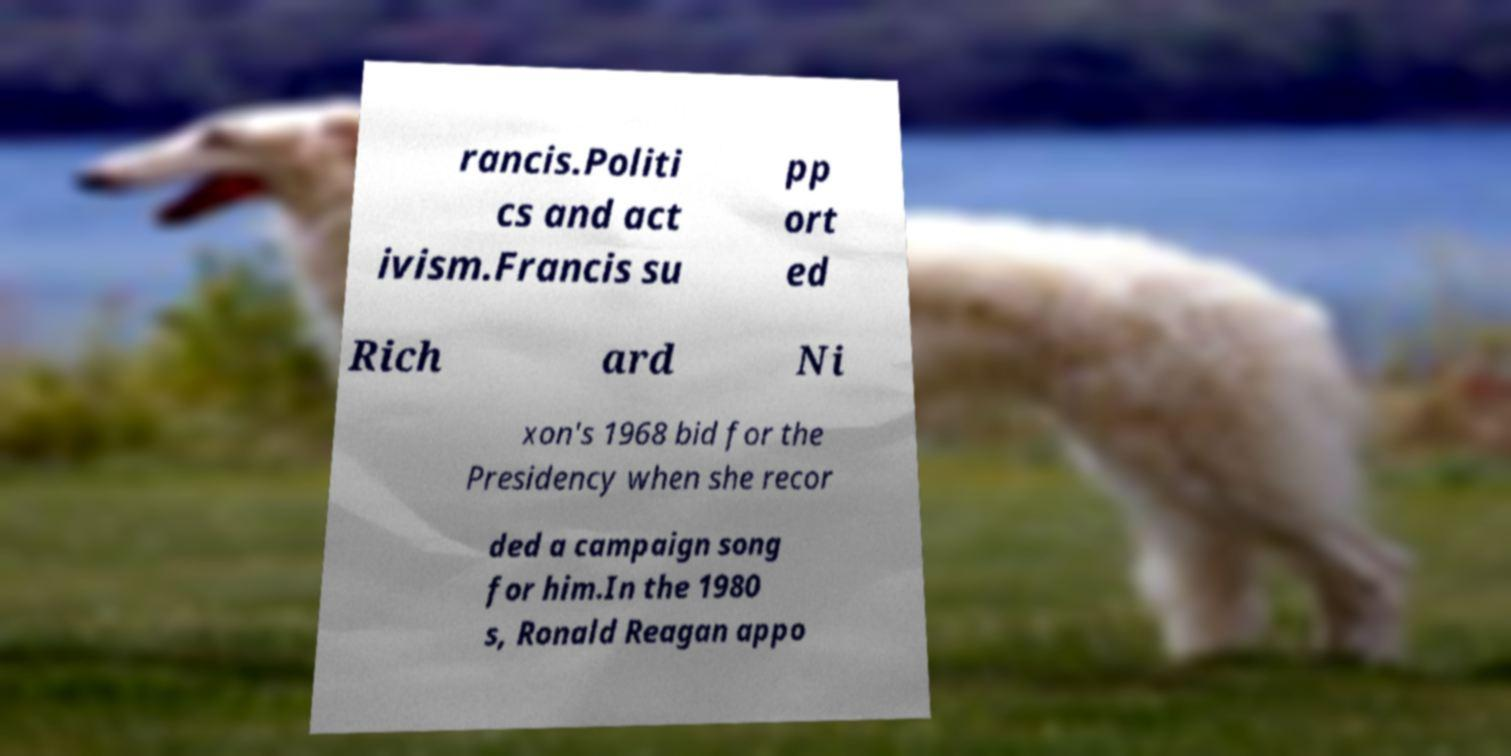Could you assist in decoding the text presented in this image and type it out clearly? rancis.Politi cs and act ivism.Francis su pp ort ed Rich ard Ni xon's 1968 bid for the Presidency when she recor ded a campaign song for him.In the 1980 s, Ronald Reagan appo 